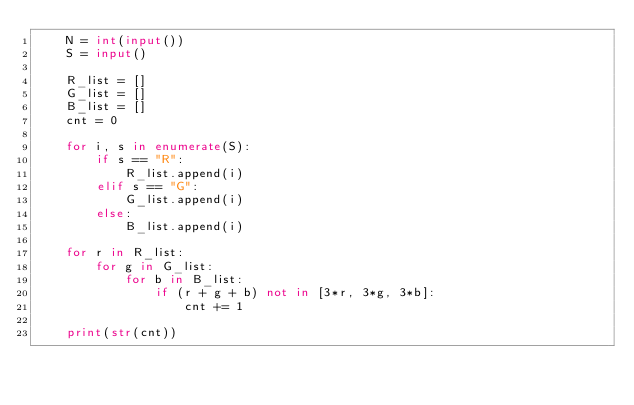Convert code to text. <code><loc_0><loc_0><loc_500><loc_500><_Python_>    N = int(input())
    S = input()
     
    R_list = []
    G_list = []
    B_list = []
    cnt = 0
     
    for i, s in enumerate(S):
        if s == "R":
            R_list.append(i)
        elif s == "G":
            G_list.append(i)
        else:
            B_list.append(i)
            
    for r in R_list:
        for g in G_list:
            for b in B_list:
                if (r + g + b) not in [3*r, 3*g, 3*b]:
                    cnt += 1
     
    print(str(cnt))</code> 